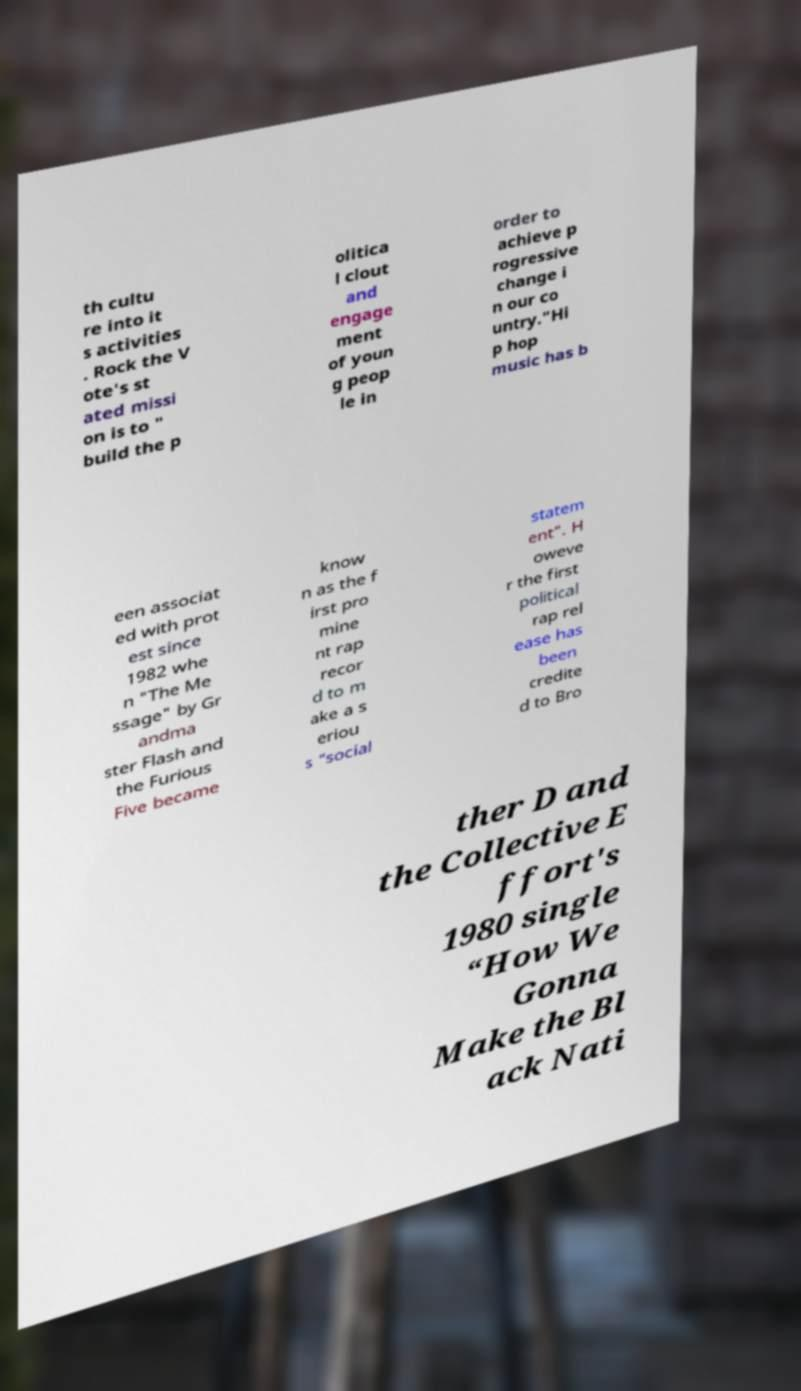Can you read and provide the text displayed in the image?This photo seems to have some interesting text. Can you extract and type it out for me? th cultu re into it s activities . Rock the V ote's st ated missi on is to " build the p olitica l clout and engage ment of youn g peop le in order to achieve p rogressive change i n our co untry."Hi p hop music has b een associat ed with prot est since 1982 whe n "The Me ssage" by Gr andma ster Flash and the Furious Five became know n as the f irst pro mine nt rap recor d to m ake a s eriou s “social statem ent”. H oweve r the first political rap rel ease has been credite d to Bro ther D and the Collective E ffort's 1980 single “How We Gonna Make the Bl ack Nati 